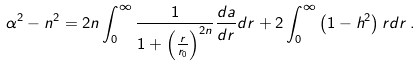Convert formula to latex. <formula><loc_0><loc_0><loc_500><loc_500>\alpha ^ { 2 } - n ^ { 2 } = 2 n \int _ { 0 } ^ { \infty } { \frac { 1 } { 1 + \left ( { \frac { r } { r _ { 0 } } } \right ) ^ { 2 n } } } { \frac { d a } { d r } } d r + 2 \int _ { 0 } ^ { \infty } \left ( 1 - h ^ { 2 } \right ) r d r \, .</formula> 